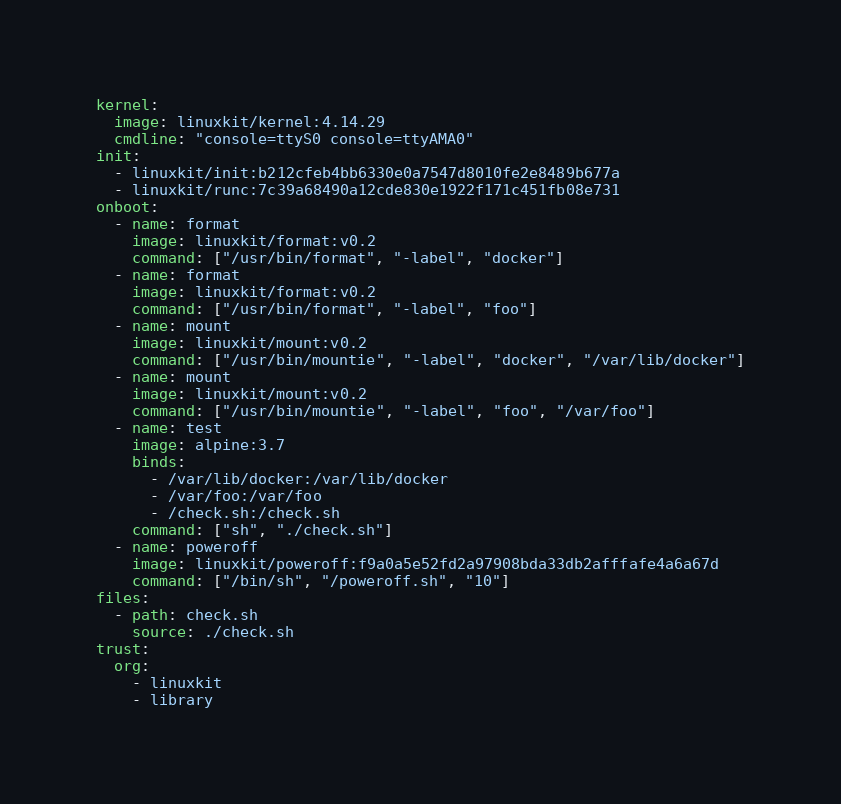<code> <loc_0><loc_0><loc_500><loc_500><_YAML_>kernel:
  image: linuxkit/kernel:4.14.29
  cmdline: "console=ttyS0 console=ttyAMA0"
init:
  - linuxkit/init:b212cfeb4bb6330e0a7547d8010fe2e8489b677a
  - linuxkit/runc:7c39a68490a12cde830e1922f171c451fb08e731
onboot:
  - name: format
    image: linuxkit/format:v0.2
    command: ["/usr/bin/format", "-label", "docker"]
  - name: format
    image: linuxkit/format:v0.2
    command: ["/usr/bin/format", "-label", "foo"]
  - name: mount
    image: linuxkit/mount:v0.2
    command: ["/usr/bin/mountie", "-label", "docker", "/var/lib/docker"]
  - name: mount
    image: linuxkit/mount:v0.2
    command: ["/usr/bin/mountie", "-label", "foo", "/var/foo"]
  - name: test
    image: alpine:3.7
    binds:
      - /var/lib/docker:/var/lib/docker
      - /var/foo:/var/foo
      - /check.sh:/check.sh
    command: ["sh", "./check.sh"]
  - name: poweroff
    image: linuxkit/poweroff:f9a0a5e52fd2a97908bda33db2afffafe4a6a67d
    command: ["/bin/sh", "/poweroff.sh", "10"]
files:
  - path: check.sh
    source: ./check.sh
trust:
  org:
    - linuxkit
    - library
</code> 